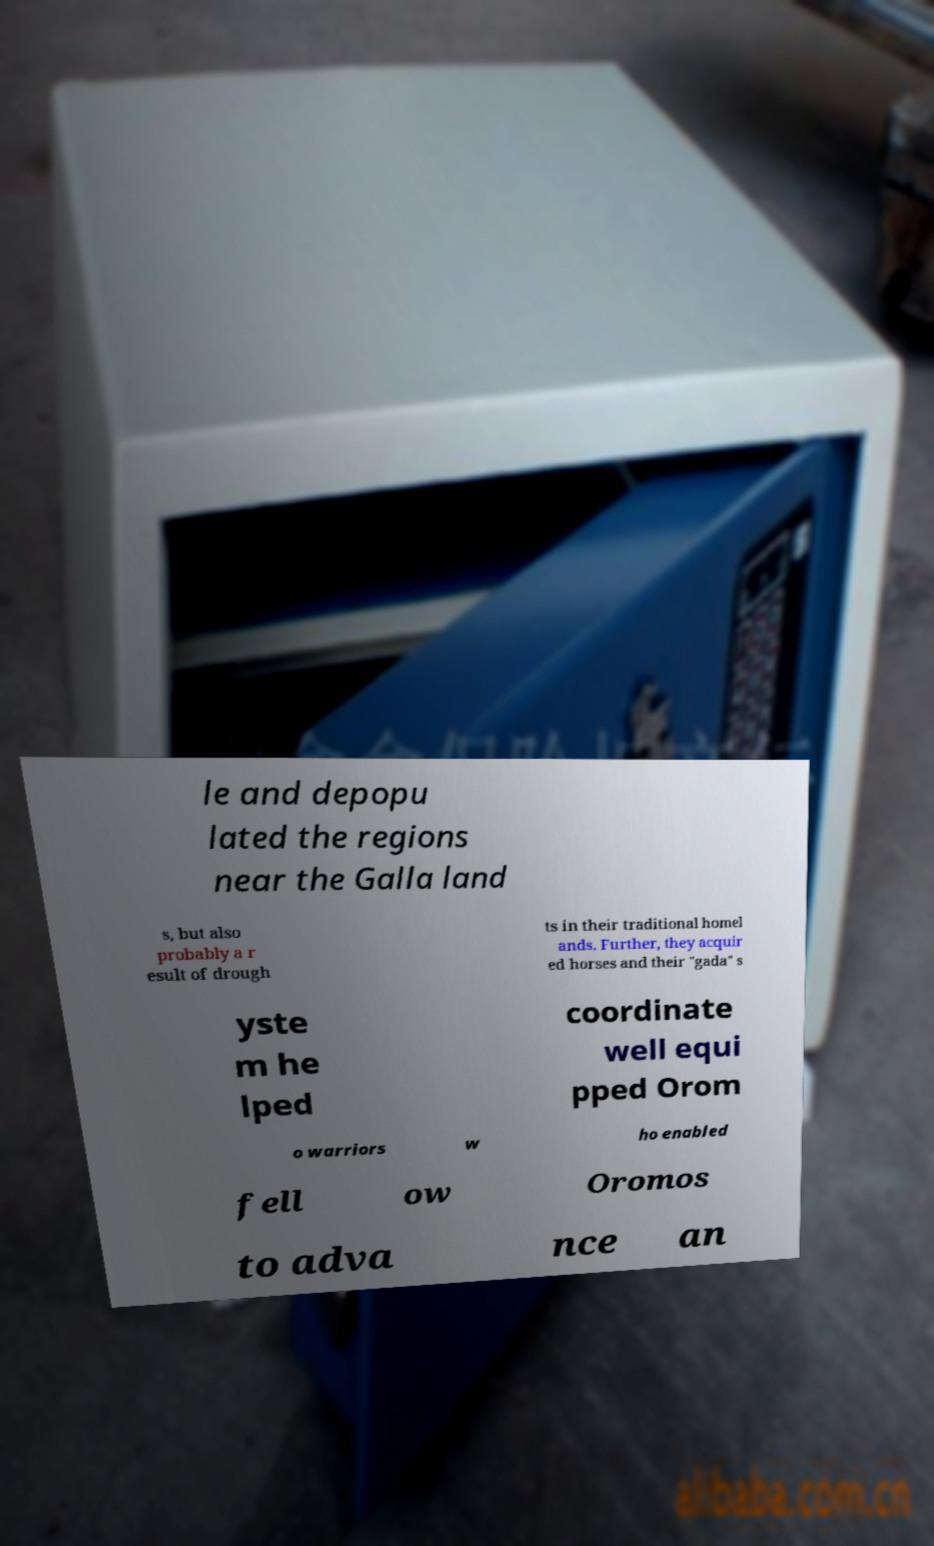Can you read and provide the text displayed in the image?This photo seems to have some interesting text. Can you extract and type it out for me? le and depopu lated the regions near the Galla land s, but also probably a r esult of drough ts in their traditional homel ands. Further, they acquir ed horses and their "gada" s yste m he lped coordinate well equi pped Orom o warriors w ho enabled fell ow Oromos to adva nce an 